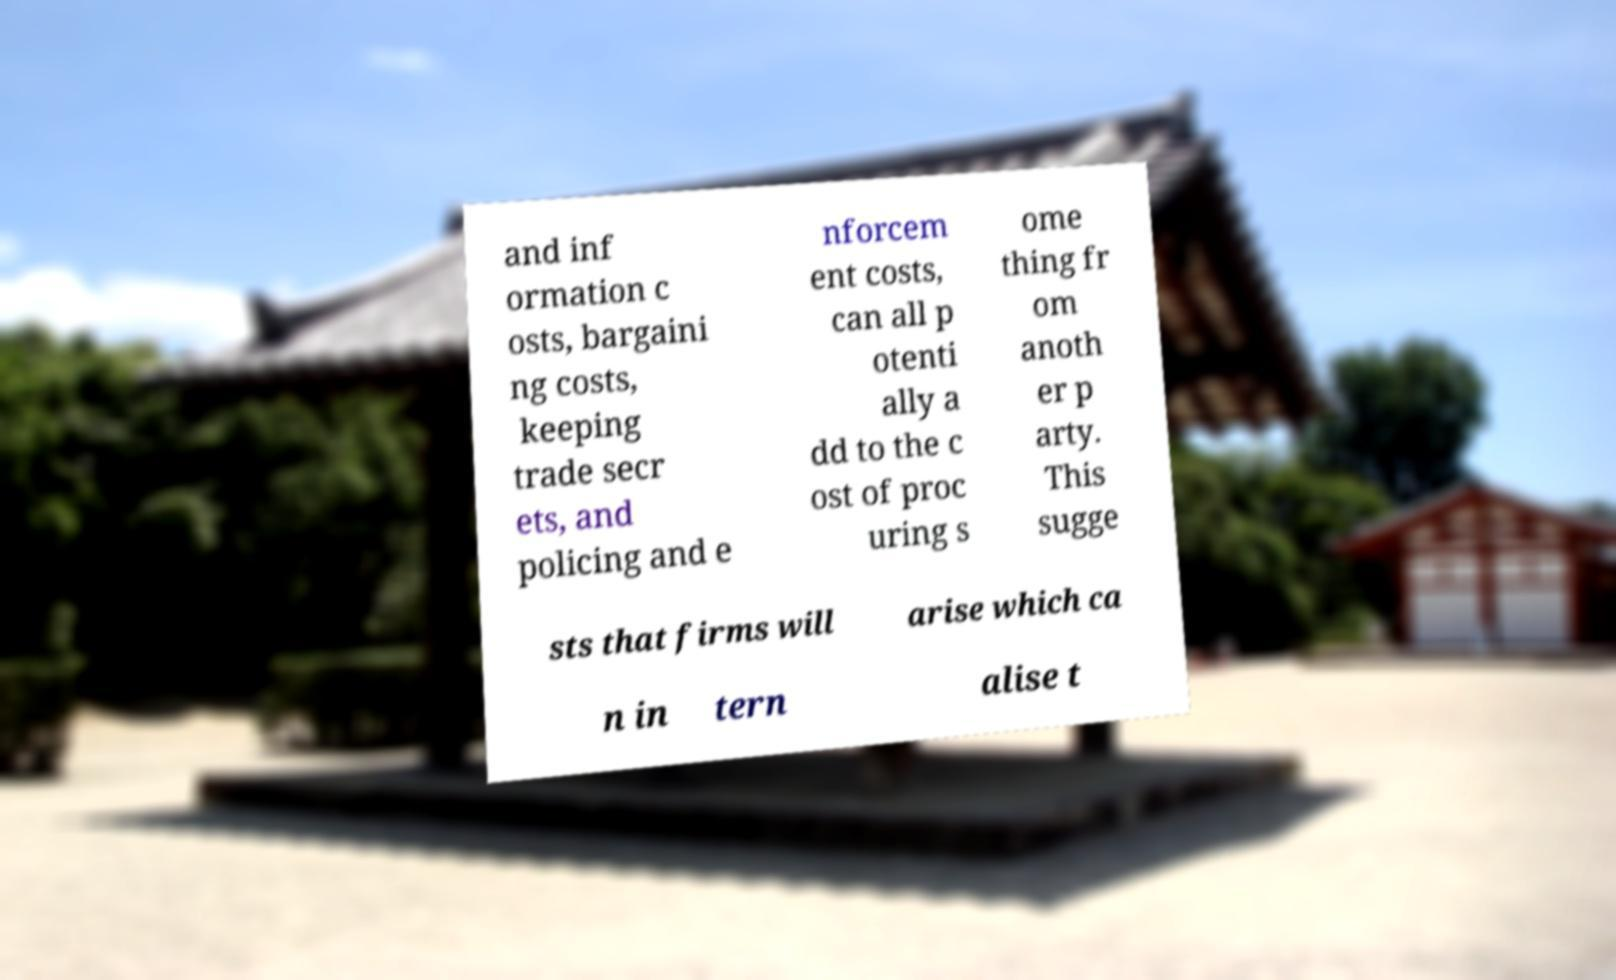Could you assist in decoding the text presented in this image and type it out clearly? and inf ormation c osts, bargaini ng costs, keeping trade secr ets, and policing and e nforcem ent costs, can all p otenti ally a dd to the c ost of proc uring s ome thing fr om anoth er p arty. This sugge sts that firms will arise which ca n in tern alise t 